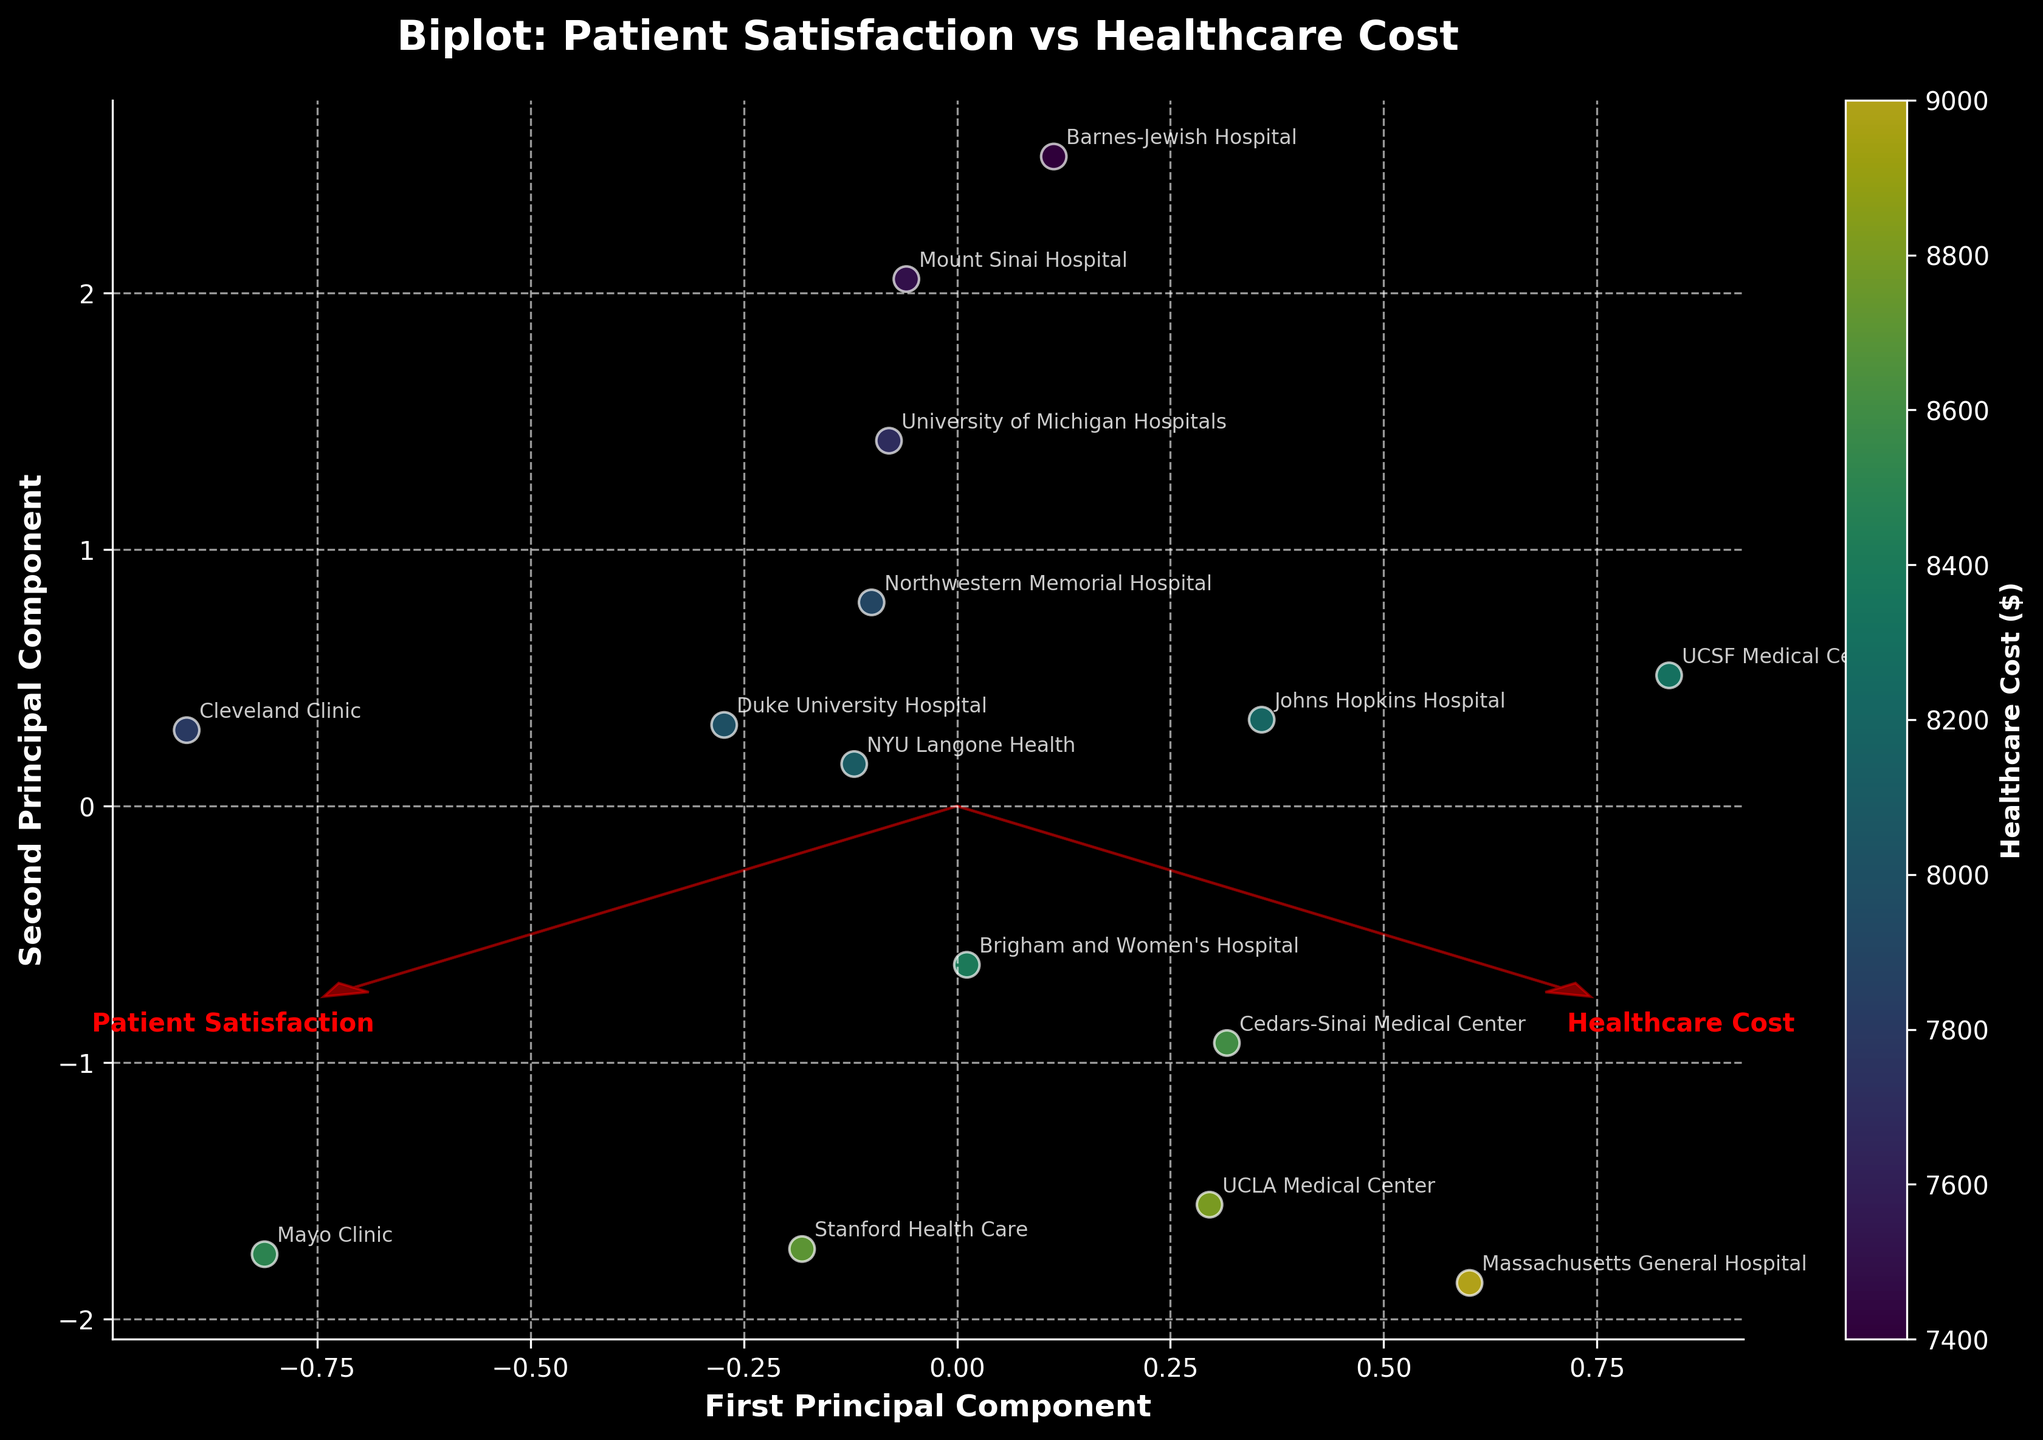What is the title of the plot? The title of the plot is written at the top of the figure and provides the main description of what is being visualized.
Answer: Biplot: Patient Satisfaction vs Healthcare Cost How many data points are plotted? In the scatter plot section of the biplot, each point represents a hospital. Counting these points will give the total number of data points plotted.
Answer: 15 Which hospital has the highest patient satisfaction score? To find this, look at the arrows or text annotations and identify the hospital positioned farthest in the direction of the 'Patient Satisfaction' vector.
Answer: Mayo Clinic Which hospital has the lowest healthcare cost? The color gradient indicates healthcare costs, with the lightest colors representing the lowest costs. Identify the lightest color point and refer to its annotation.
Answer: Mount Sinai Hospital How are the features 'Patient Satisfaction' and 'Healthcare Cost' represented in the biplot? These features are visualized as arrows originating from the origin (0, 0). Their direction and length represent the contribution of each feature to the principal components.
Answer: As red arrows Which hospital appears closest to the origin (0, 0) in the plot? Locate the point nearest the origin from the scatter plot section of the biplot and read its annotation.
Answer: University of Michigan Hospitals How do 'Patient Satisfaction' and 'Healthcare Cost' correlate according to the biplot? By analyzing the direction and proximity of the Patient Satisfaction and Healthcare Cost vectors, you can determine their correlation. If they point in similar directions, they are positively correlated; if opposite, negatively.
Answer: Positively correlated Which component has the higher loading on 'Healthcare Cost'? The length and direction of the feature vectors can indicate how each principal component loads on the original features. Identify which principal component aligns more with the Healthcare Cost vector.
Answer: First Principal Component Are any hospitals with above-average Healthcare Costs also above average in Patient Satisfaction? Determine the average values for Patient Satisfaction and Healthcare Cost, then find hospitals plotted in the quadrant representing above-average values for both.
Answer: Yes (e.g., Stanford Health Care, UCLA Medical Center) What can be inferred about Northwestern Memorial Hospital based on its position in the biplot? Observe Northwestern Memorial Hospital's position relative to the Patient Satisfaction and Healthcare Cost vectors. This inference will incorporate its deviations from the mean in both dimensions.
Answer: It has moderate patient satisfaction and healthcare cost 